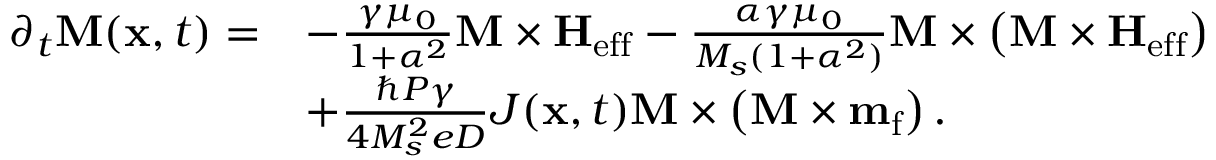Convert formula to latex. <formula><loc_0><loc_0><loc_500><loc_500>\begin{array} { r l } { \partial _ { t } { M } ( { x } , t ) = } & { - \frac { \gamma \mu _ { 0 } } { 1 + \alpha ^ { 2 } } { M } \times { H } _ { e f f } - \frac { \alpha \gamma \mu _ { 0 } } { M _ { s } ( 1 + \alpha ^ { 2 } ) } { M } \times \left ( { M } \times { H } _ { e f f } \right ) } \\ & { + \frac { \hbar { P } \gamma } { 4 M _ { s } ^ { 2 } e D } J ( { x } , t ) { M } \times \left ( { M } \times { m } _ { f } \right ) . } \end{array}</formula> 